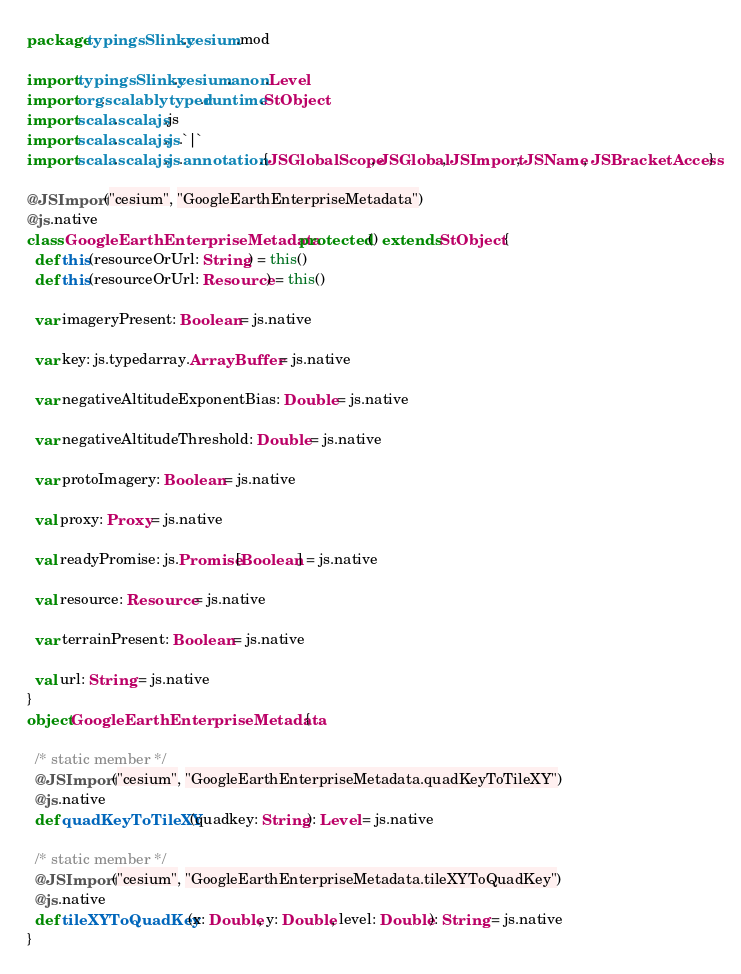Convert code to text. <code><loc_0><loc_0><loc_500><loc_500><_Scala_>package typingsSlinky.cesium.mod

import typingsSlinky.cesium.anon.Level
import org.scalablytyped.runtime.StObject
import scala.scalajs.js
import scala.scalajs.js.`|`
import scala.scalajs.js.annotation.{JSGlobalScope, JSGlobal, JSImport, JSName, JSBracketAccess}

@JSImport("cesium", "GoogleEarthEnterpriseMetadata")
@js.native
class GoogleEarthEnterpriseMetadata protected () extends StObject {
  def this(resourceOrUrl: String) = this()
  def this(resourceOrUrl: Resource) = this()
  
  var imageryPresent: Boolean = js.native
  
  var key: js.typedarray.ArrayBuffer = js.native
  
  var negativeAltitudeExponentBias: Double = js.native
  
  var negativeAltitudeThreshold: Double = js.native
  
  var protoImagery: Boolean = js.native
  
  val proxy: Proxy = js.native
  
  val readyPromise: js.Promise[Boolean] = js.native
  
  val resource: Resource = js.native
  
  var terrainPresent: Boolean = js.native
  
  val url: String = js.native
}
object GoogleEarthEnterpriseMetadata {
  
  /* static member */
  @JSImport("cesium", "GoogleEarthEnterpriseMetadata.quadKeyToTileXY")
  @js.native
  def quadKeyToTileXY(quadkey: String): Level = js.native
  
  /* static member */
  @JSImport("cesium", "GoogleEarthEnterpriseMetadata.tileXYToQuadKey")
  @js.native
  def tileXYToQuadKey(x: Double, y: Double, level: Double): String = js.native
}
</code> 